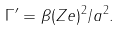Convert formula to latex. <formula><loc_0><loc_0><loc_500><loc_500>\Gamma ^ { \prime } = \beta ( Z e ) ^ { 2 } / a ^ { 2 } .</formula> 